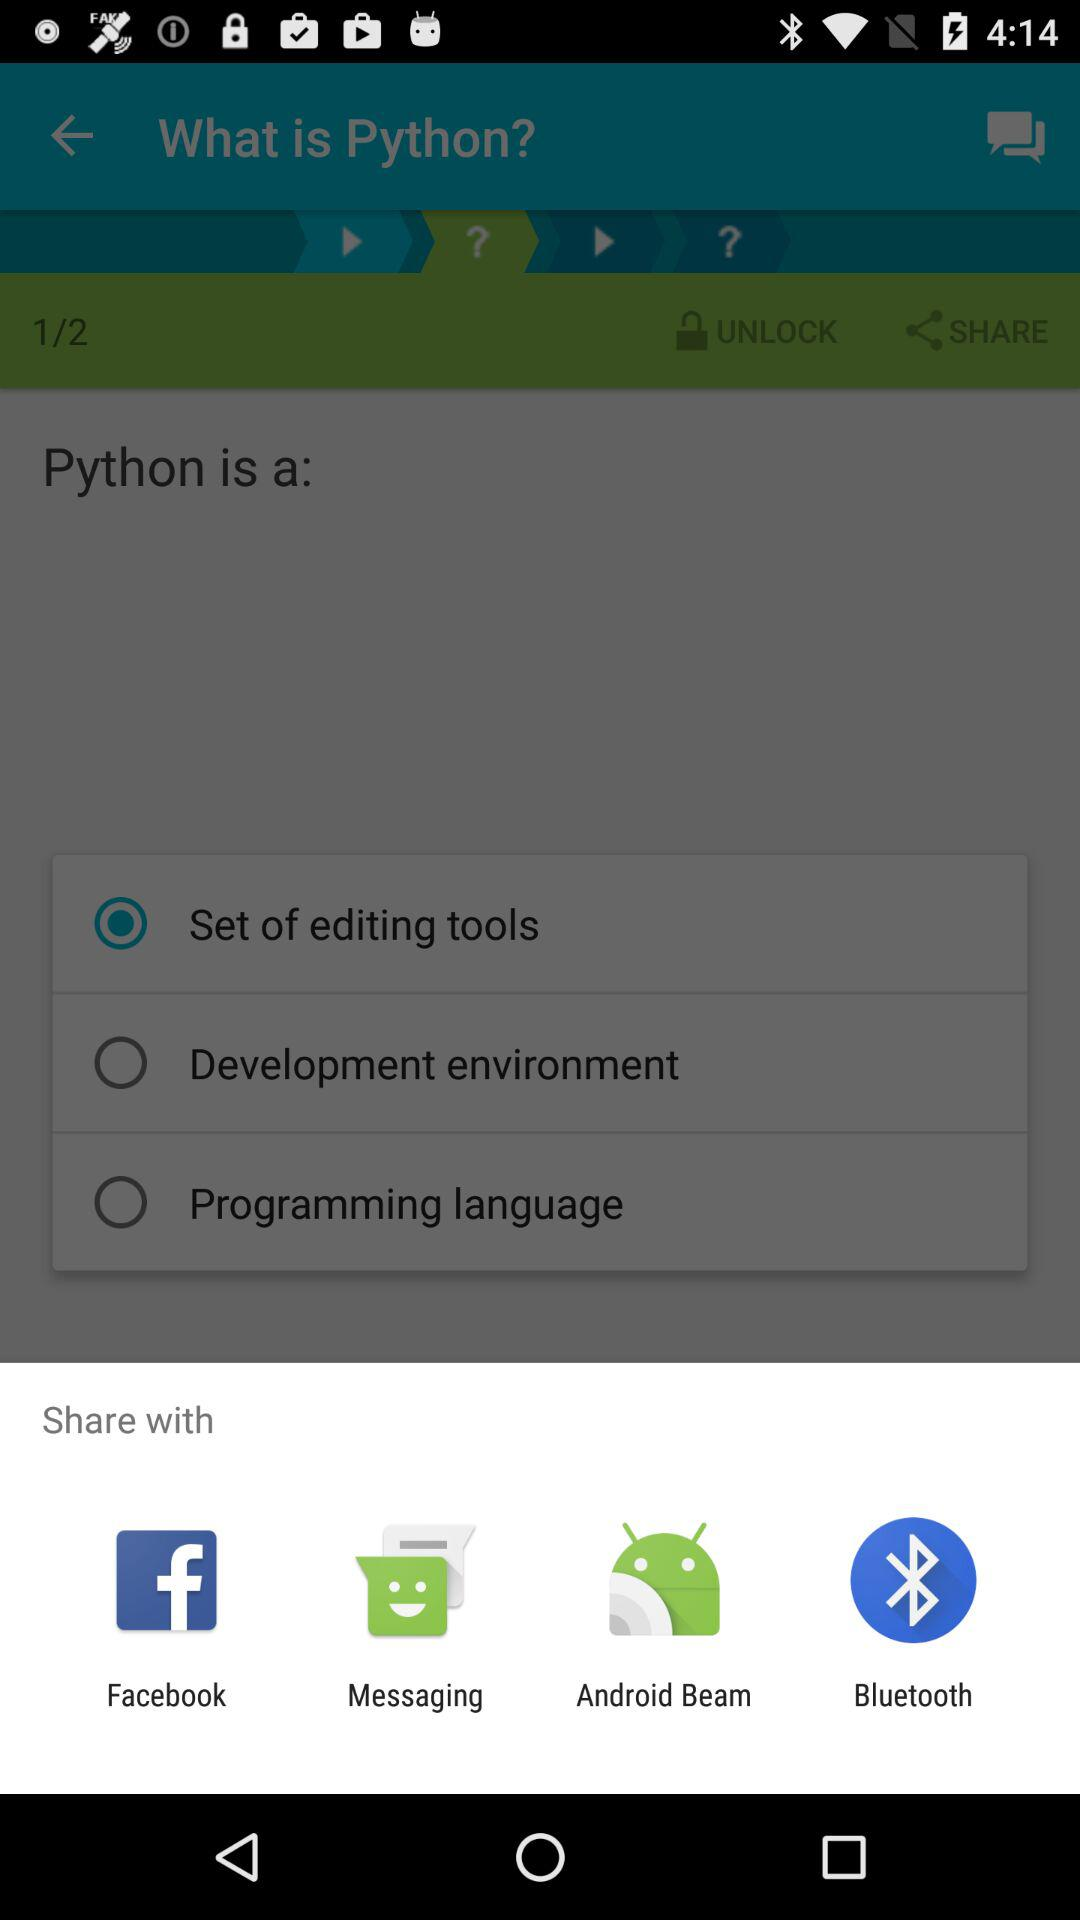With which app can we share? You can share with "Facebook", "Messaging", "Android Beam" and "Bluetooth". 